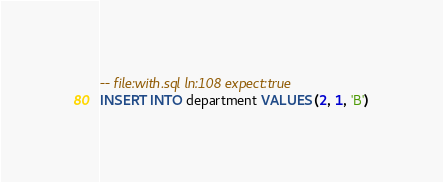Convert code to text. <code><loc_0><loc_0><loc_500><loc_500><_SQL_>-- file:with.sql ln:108 expect:true
INSERT INTO department VALUES (2, 1, 'B')
</code> 